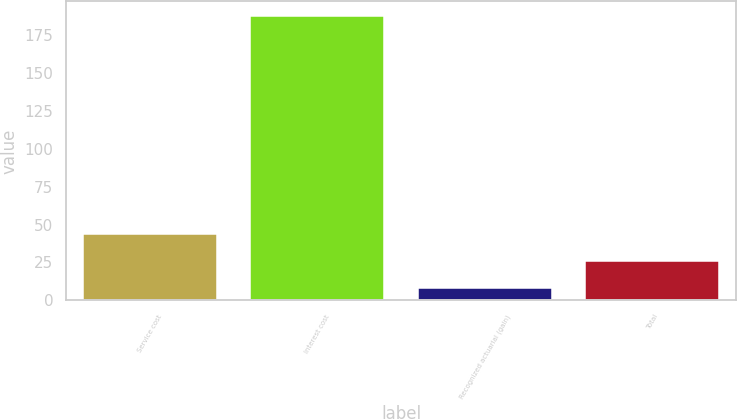Convert chart to OTSL. <chart><loc_0><loc_0><loc_500><loc_500><bar_chart><fcel>Service cost<fcel>Interest cost<fcel>Recognized actuarial (gain)<fcel>Total<nl><fcel>44<fcel>188<fcel>8<fcel>26<nl></chart> 